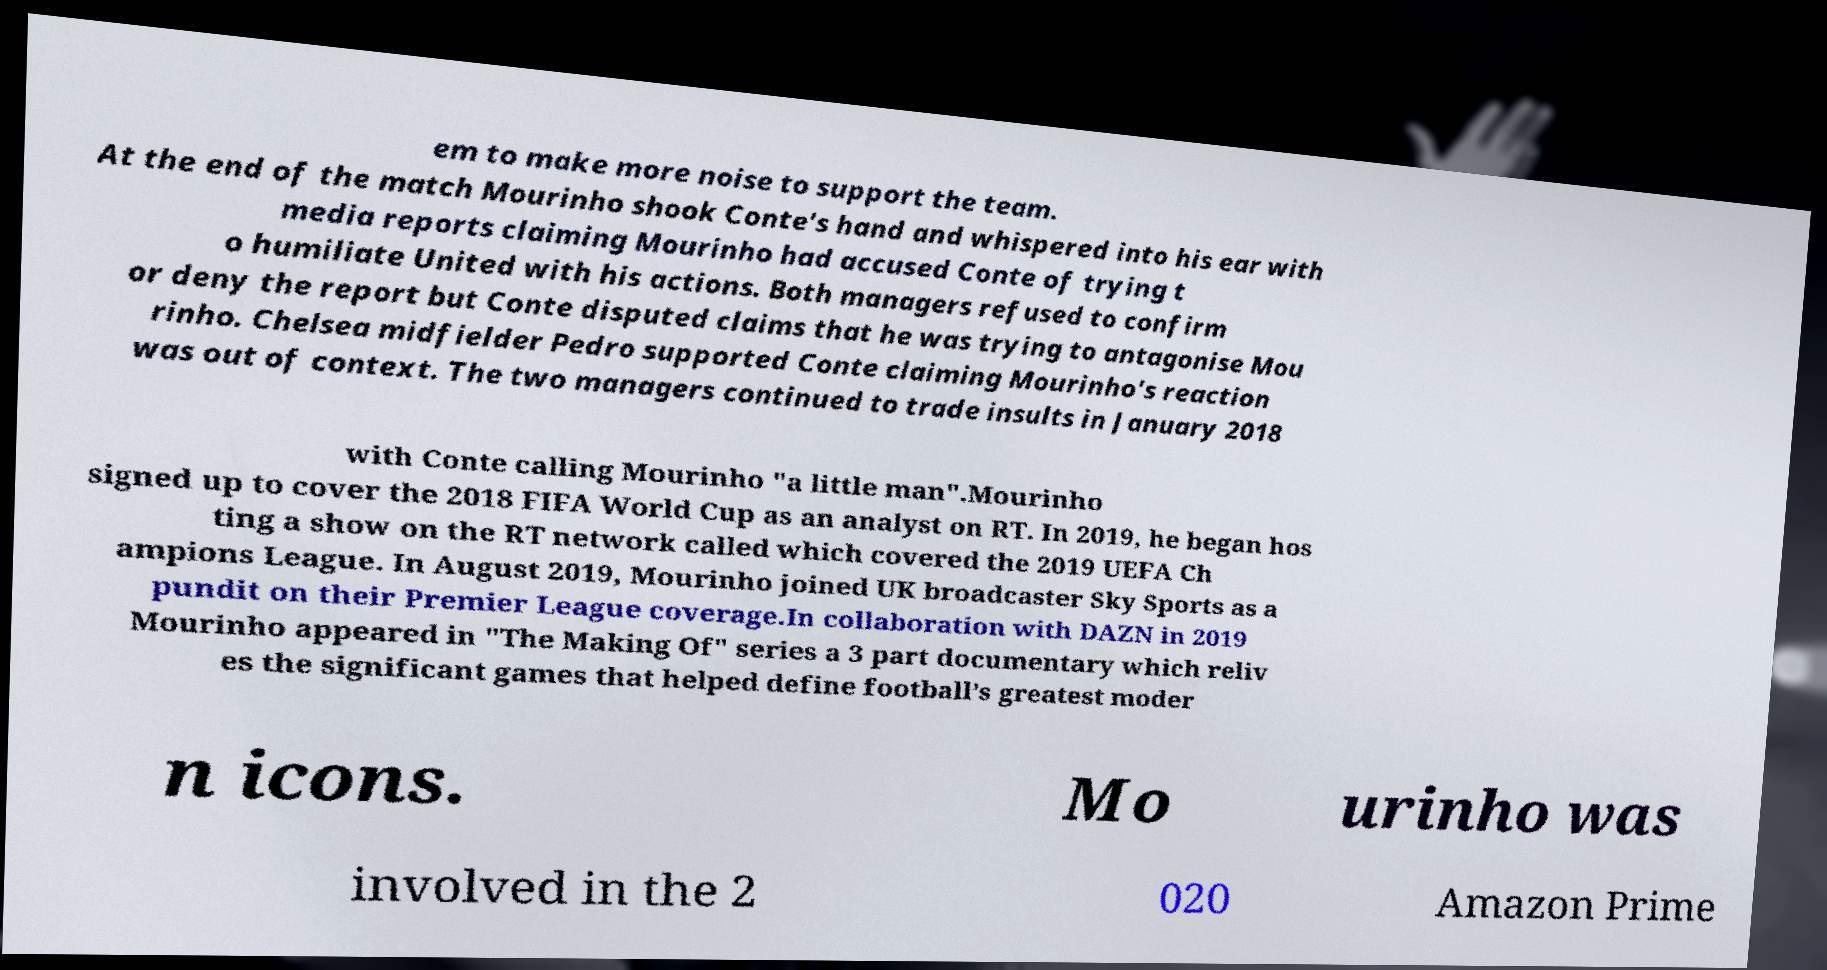Could you extract and type out the text from this image? em to make more noise to support the team. At the end of the match Mourinho shook Conte's hand and whispered into his ear with media reports claiming Mourinho had accused Conte of trying t o humiliate United with his actions. Both managers refused to confirm or deny the report but Conte disputed claims that he was trying to antagonise Mou rinho. Chelsea midfielder Pedro supported Conte claiming Mourinho's reaction was out of context. The two managers continued to trade insults in January 2018 with Conte calling Mourinho "a little man".Mourinho signed up to cover the 2018 FIFA World Cup as an analyst on RT. In 2019, he began hos ting a show on the RT network called which covered the 2019 UEFA Ch ampions League. In August 2019, Mourinho joined UK broadcaster Sky Sports as a pundit on their Premier League coverage.In collaboration with DAZN in 2019 Mourinho appeared in "The Making Of" series a 3 part documentary which reliv es the significant games that helped define football’s greatest moder n icons. Mo urinho was involved in the 2 020 Amazon Prime 